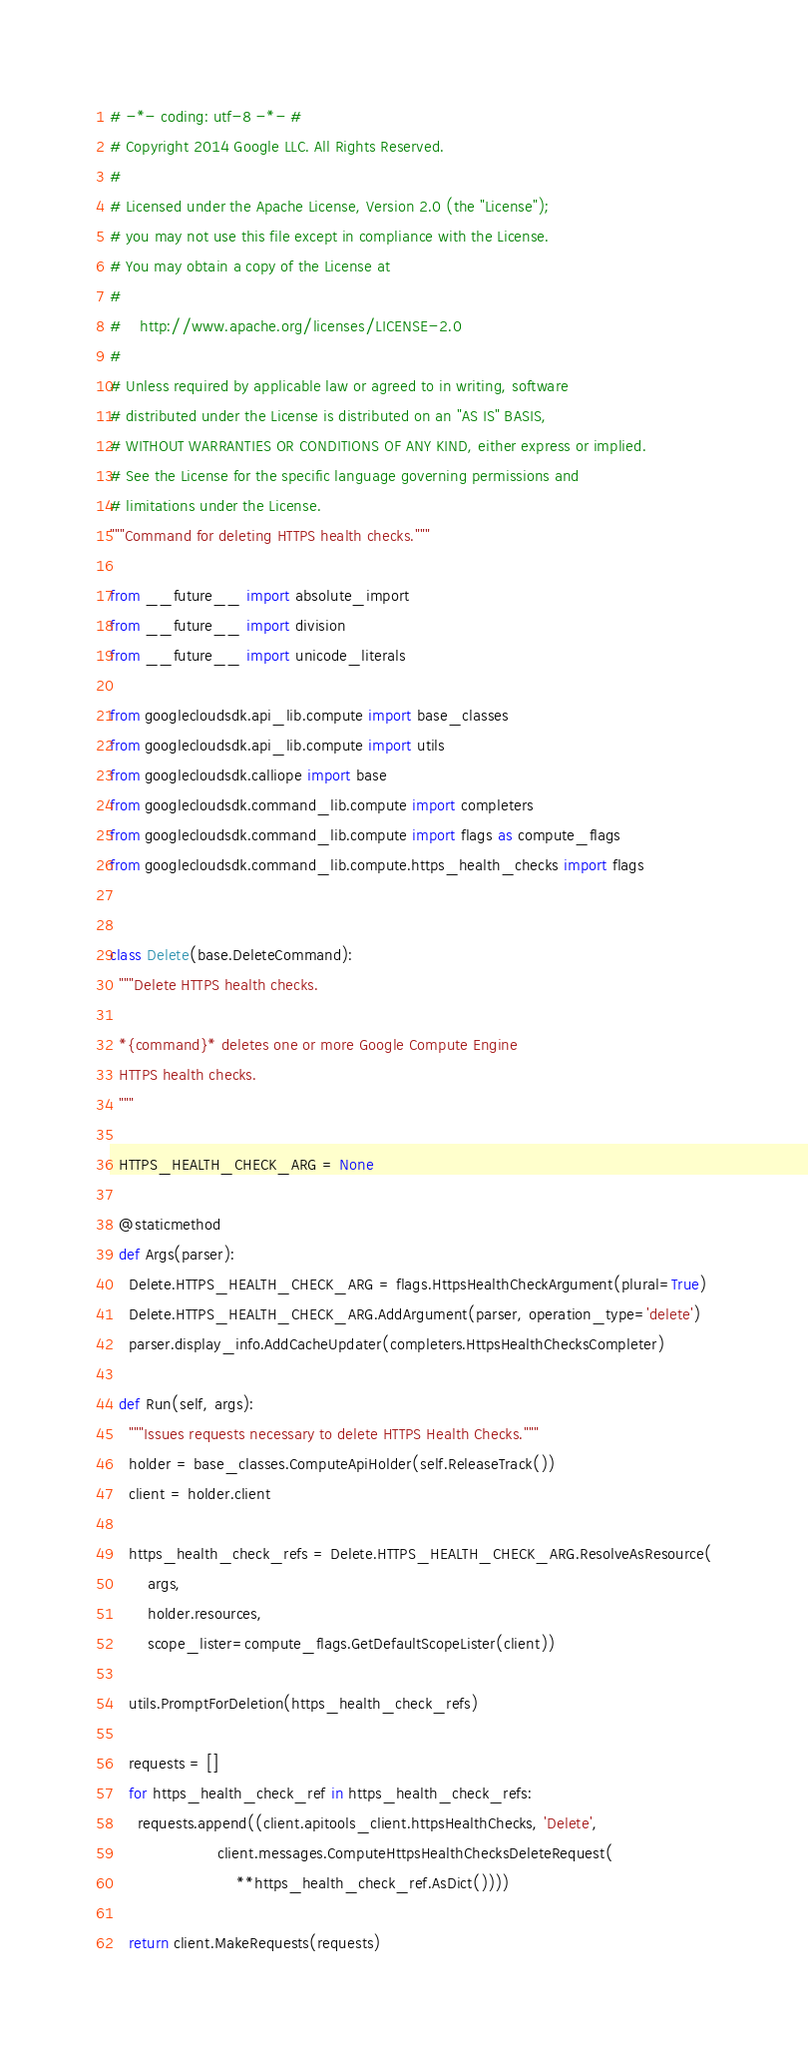<code> <loc_0><loc_0><loc_500><loc_500><_Python_># -*- coding: utf-8 -*- #
# Copyright 2014 Google LLC. All Rights Reserved.
#
# Licensed under the Apache License, Version 2.0 (the "License");
# you may not use this file except in compliance with the License.
# You may obtain a copy of the License at
#
#    http://www.apache.org/licenses/LICENSE-2.0
#
# Unless required by applicable law or agreed to in writing, software
# distributed under the License is distributed on an "AS IS" BASIS,
# WITHOUT WARRANTIES OR CONDITIONS OF ANY KIND, either express or implied.
# See the License for the specific language governing permissions and
# limitations under the License.
"""Command for deleting HTTPS health checks."""

from __future__ import absolute_import
from __future__ import division
from __future__ import unicode_literals

from googlecloudsdk.api_lib.compute import base_classes
from googlecloudsdk.api_lib.compute import utils
from googlecloudsdk.calliope import base
from googlecloudsdk.command_lib.compute import completers
from googlecloudsdk.command_lib.compute import flags as compute_flags
from googlecloudsdk.command_lib.compute.https_health_checks import flags


class Delete(base.DeleteCommand):
  """Delete HTTPS health checks.

  *{command}* deletes one or more Google Compute Engine
  HTTPS health checks.
  """

  HTTPS_HEALTH_CHECK_ARG = None

  @staticmethod
  def Args(parser):
    Delete.HTTPS_HEALTH_CHECK_ARG = flags.HttpsHealthCheckArgument(plural=True)
    Delete.HTTPS_HEALTH_CHECK_ARG.AddArgument(parser, operation_type='delete')
    parser.display_info.AddCacheUpdater(completers.HttpsHealthChecksCompleter)

  def Run(self, args):
    """Issues requests necessary to delete HTTPS Health Checks."""
    holder = base_classes.ComputeApiHolder(self.ReleaseTrack())
    client = holder.client

    https_health_check_refs = Delete.HTTPS_HEALTH_CHECK_ARG.ResolveAsResource(
        args,
        holder.resources,
        scope_lister=compute_flags.GetDefaultScopeLister(client))

    utils.PromptForDeletion(https_health_check_refs)

    requests = []
    for https_health_check_ref in https_health_check_refs:
      requests.append((client.apitools_client.httpsHealthChecks, 'Delete',
                       client.messages.ComputeHttpsHealthChecksDeleteRequest(
                           **https_health_check_ref.AsDict())))

    return client.MakeRequests(requests)
</code> 